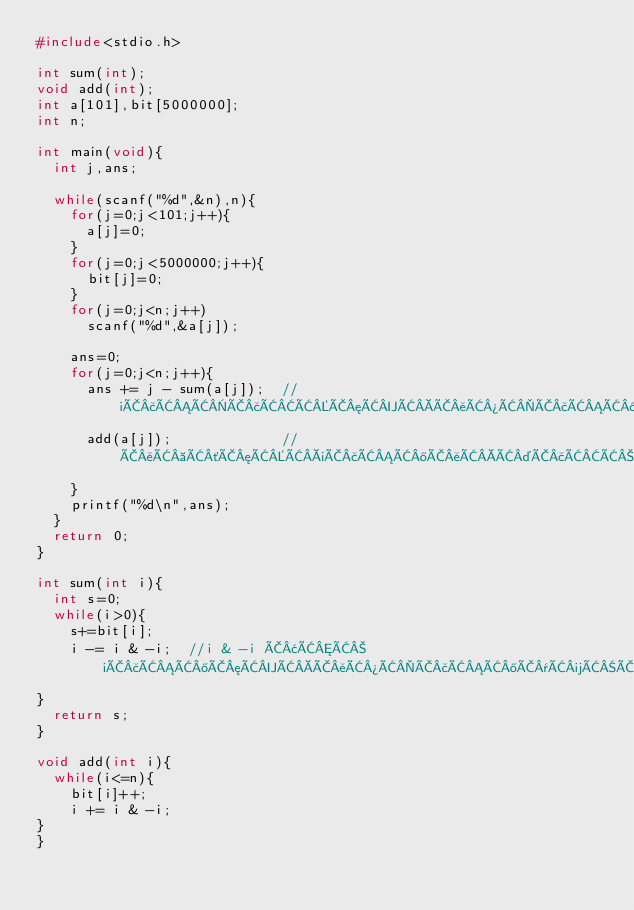Convert code to text. <code><loc_0><loc_0><loc_500><loc_500><_C_>#include<stdio.h>

int sum(int);
void add(int);
int a[101],bit[5000000];
int n;

int main(void){
  int j,ans;

  while(scanf("%d",&n),n){
    for(j=0;j<101;j++){
      a[j]=0;
    }
    for(j=0;j<5000000;j++){
      bit[j]=0;
    }
    for(j=0;j<n;j++)
      scanf("%d",&a[j]);
    
    ans=0;
    for(j=0;j<n;j++){
      ans += j - sum(a[j]);  //iÃ£ÂÂÃ£ÂÂÃ¦ÂÂÃ¥Â¾ÂÃ£ÂÂ®Ã¯Â¼ÂÃ£ÂÂ®Ã£ÂÂÃ£ÂÂÃ£ÂÂÃ£ÂÂÃ¦Â¸ÂÃ§Â®ÂÃ£ÂÂÃ£ÂÂªÃ£ÂÂÃ£ÂÂ
      add(a[j]);             //Ã¥Â Â´Ã¦ÂÂiÃ£ÂÂ®Ã¥ÂÂ¤Ã£ÂÂÃ¥ÂÂ Ã§Â®Â
    }
    printf("%d\n",ans);
  }
  return 0;
}

int sum(int i){
  int s=0;
  while(i>0){
    s+=bit[i];
    i -= i & -i;  //i & -i Ã¢ÂÂ iÃ£ÂÂ®Ã¦ÂÂÃ¥Â¾ÂÃ£ÂÂ®Ã¯Â¼ÂÃ£ÂÂ®Ã£ÂÂÃ£ÂÂÃ£ÂÂ
}
  return s;
}

void add(int i){
  while(i<=n){
    bit[i]++;
    i += i & -i;
}
}</code> 